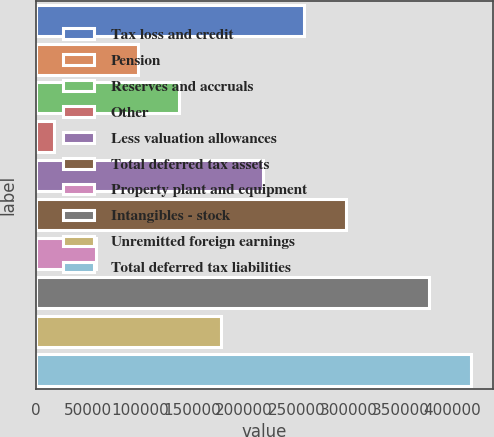Convert chart to OTSL. <chart><loc_0><loc_0><loc_500><loc_500><bar_chart><fcel>Tax loss and credit<fcel>Pension<fcel>Reserves and accruals<fcel>Other<fcel>Less valuation allowances<fcel>Total deferred tax assets<fcel>Property plant and equipment<fcel>Intangibles - stock<fcel>Unremitted foreign earnings<fcel>Total deferred tax liabilities<nl><fcel>257762<fcel>97723.4<fcel>137733<fcel>17704<fcel>217752<fcel>297772<fcel>57713.7<fcel>377791<fcel>177743<fcel>417801<nl></chart> 